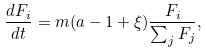<formula> <loc_0><loc_0><loc_500><loc_500>\frac { d F _ { i } } { d t } = m ( a - 1 + \xi ) \frac { F _ { i } } { \sum _ { j } F _ { j } } ,</formula> 